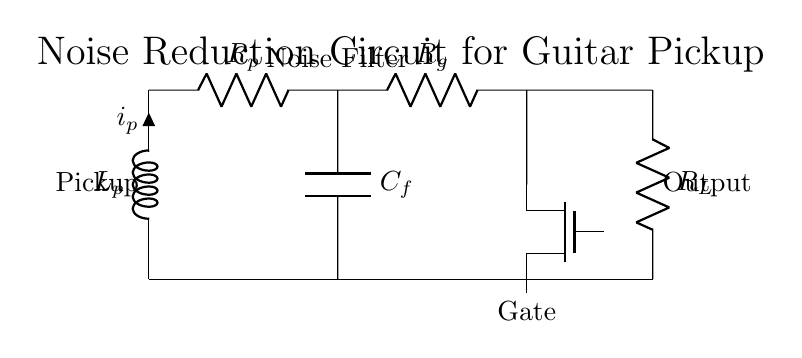What is the main purpose of this circuit? The main purpose of the circuit is to reduce noise from guitar pickups, specifically unwanted hum, by using a gate and a filter.
Answer: Noise reduction What type of inductor is represented in the circuit? The component labeled as L_p is an inductor, which models the guitar pickup's inductance.
Answer: Inductor What component is used for noise filtering? The capacitor labeled as C_f is responsible for filtering out unwanted noise from the circuit, providing AC coupling.
Answer: Capacitor What do the labels R_g and R_L represent? R_g is the gate resistor, which controls the gate of the transistor, while R_L is the load resistor connected to the output of the circuit.
Answer: Gate and load resistors How does the gate impact the noise level? The gate acts as a switch that can either allow or block the signal depending on its operation, thereby significantly reducing the noise level when activated properly.
Answer: Switch for noise What role does the capacitor play in relation to frequency? The capacitor C_f allows higher frequencies (signal) to pass while blocking lower frequencies (noise), thus distinguishing the useful part of the signal from the unwanted hum.
Answer: High-pass filter What is the configuration used in this noise reduction circuit? The circuit is a noise reduction configuration, specifically designed to eliminate hum, indicating it uses gating and filtering components effectively.
Answer: Noise reduction configuration 